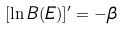Convert formula to latex. <formula><loc_0><loc_0><loc_500><loc_500>[ \ln B ( E ) ] ^ { \prime } = - \beta</formula> 